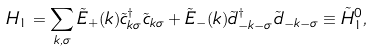<formula> <loc_0><loc_0><loc_500><loc_500>H _ { 1 } = \sum _ { k , \sigma } \tilde { E } _ { + } ( k ) \tilde { c } ^ { \dagger } _ { k \sigma } \tilde { c } _ { k \sigma } + \tilde { E } _ { - } ( k ) \tilde { d } ^ { \dagger } _ { - k - \sigma } \tilde { d } _ { - k - \sigma } \equiv \tilde { H } ^ { 0 } _ { 1 } ,</formula> 